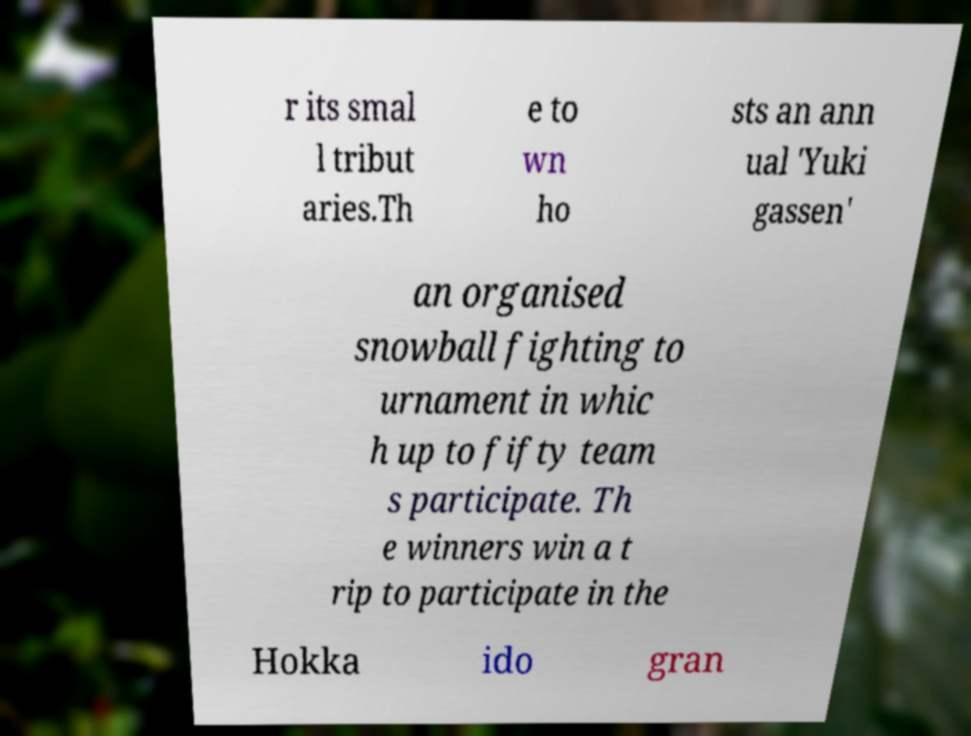I need the written content from this picture converted into text. Can you do that? r its smal l tribut aries.Th e to wn ho sts an ann ual 'Yuki gassen' an organised snowball fighting to urnament in whic h up to fifty team s participate. Th e winners win a t rip to participate in the Hokka ido gran 